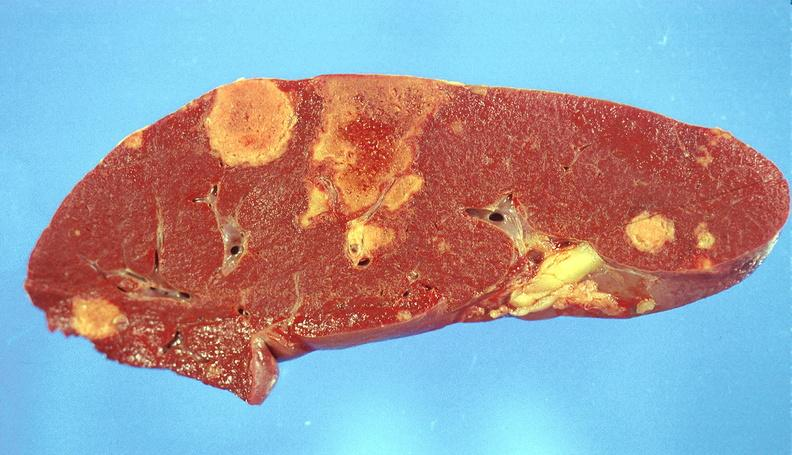does this image show splenic infarcts?
Answer the question using a single word or phrase. Yes 